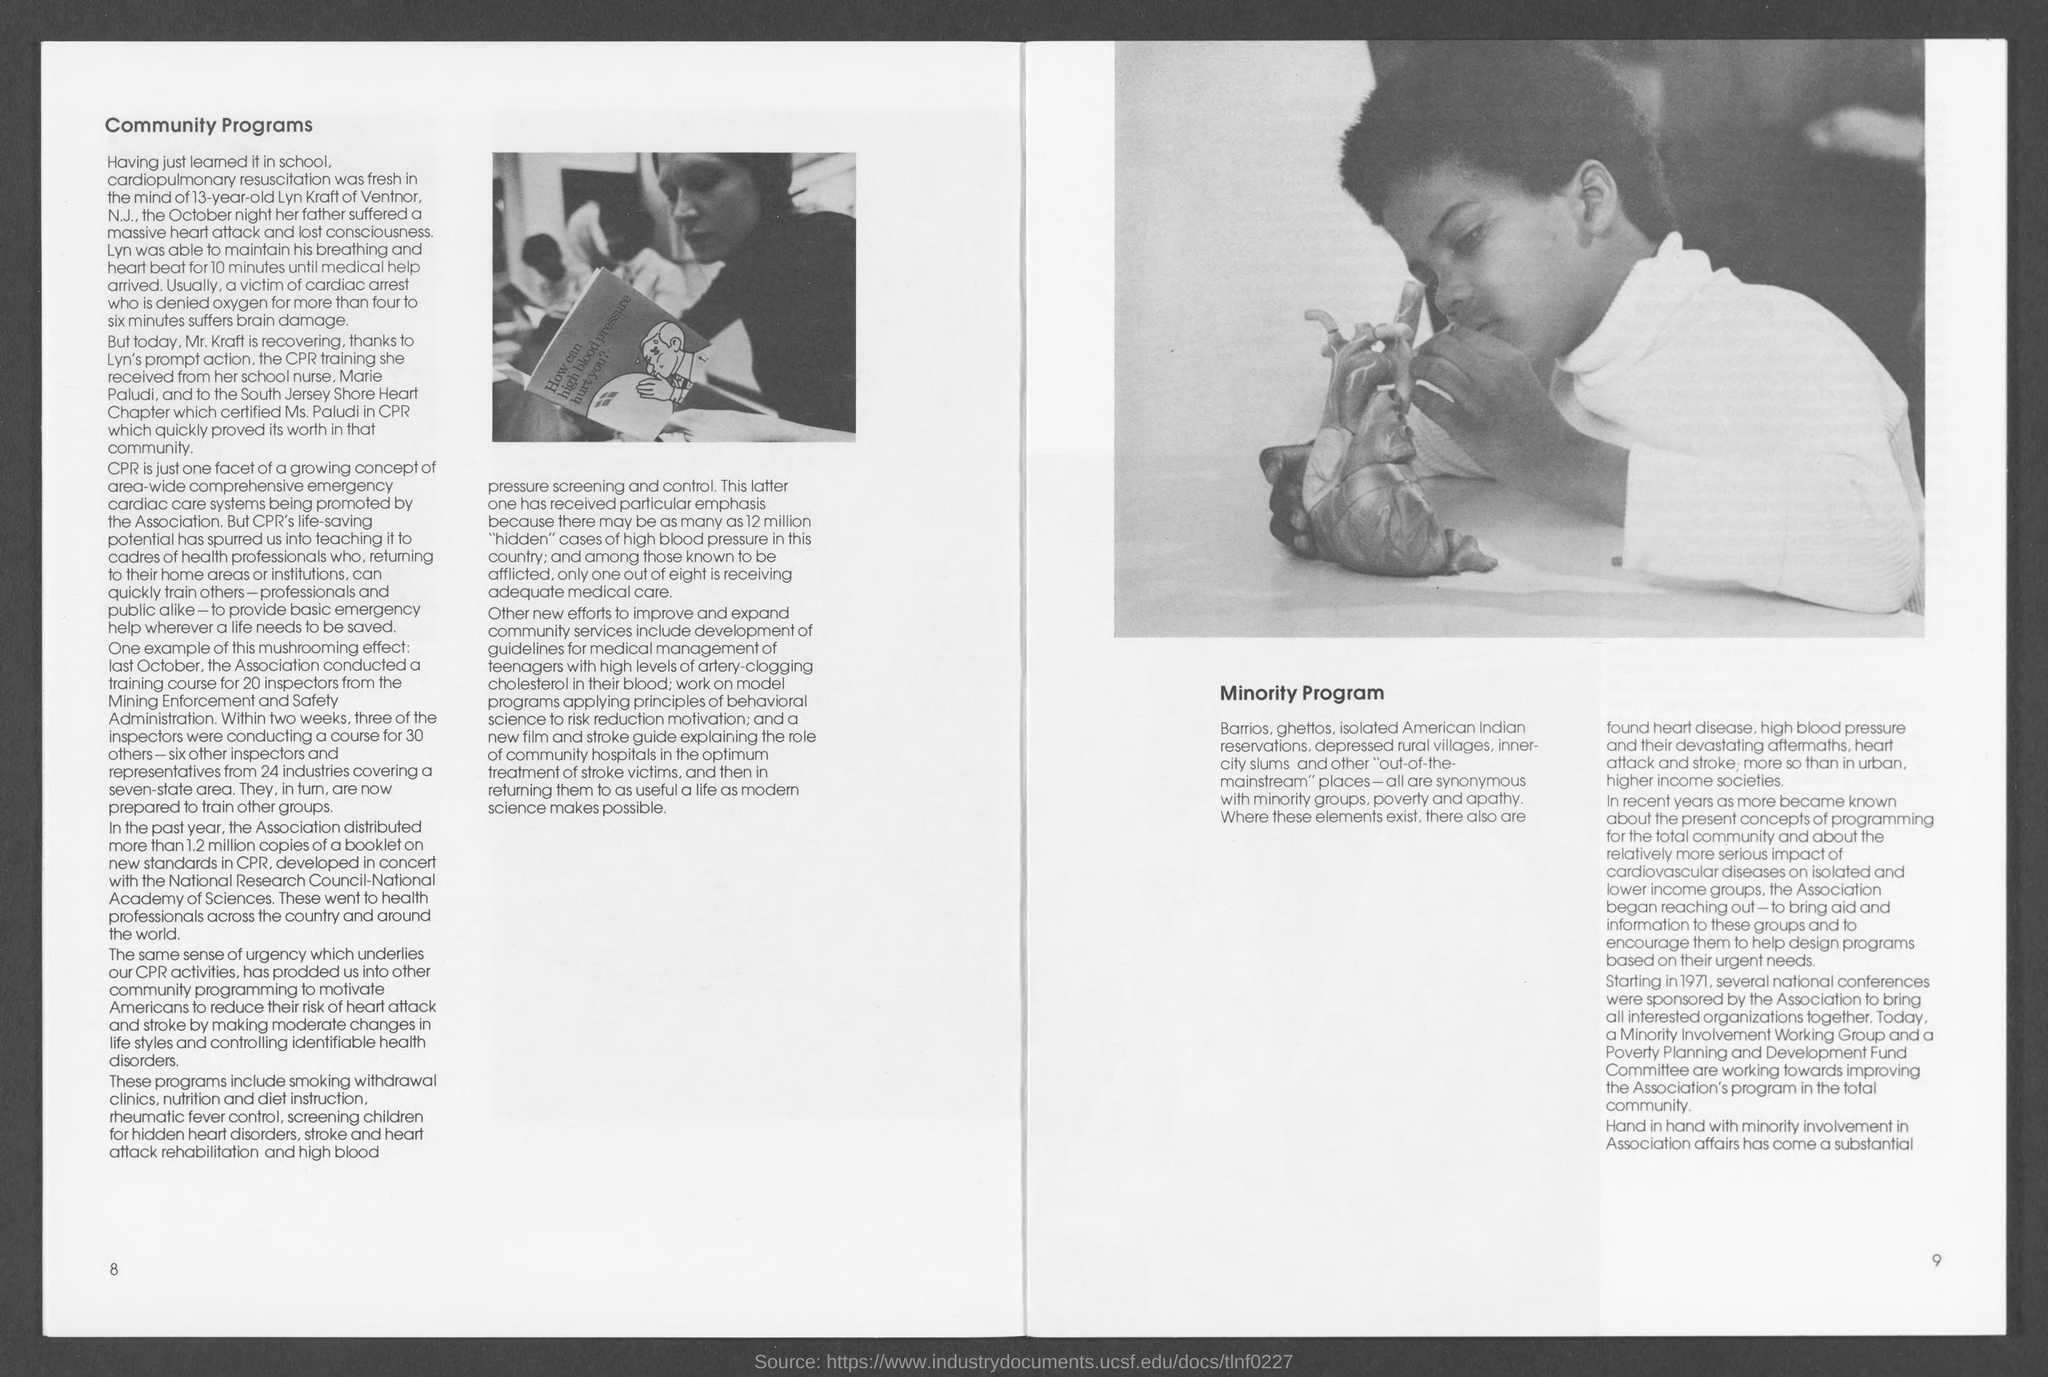Point out several critical features in this image. The heading on the left page is "Community Programs. The number at the bottom left page is 8. 